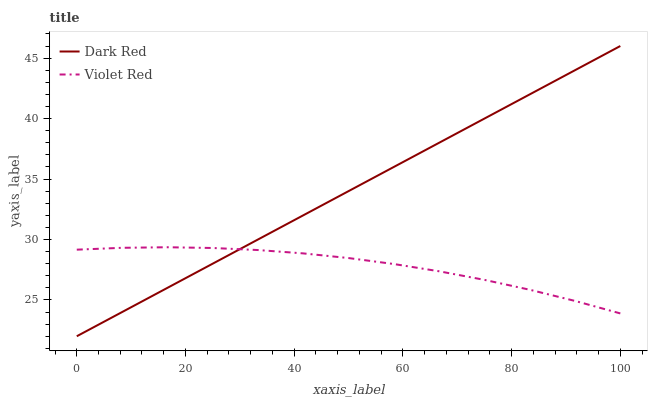Does Violet Red have the minimum area under the curve?
Answer yes or no. Yes. Does Dark Red have the maximum area under the curve?
Answer yes or no. Yes. Does Violet Red have the maximum area under the curve?
Answer yes or no. No. Is Dark Red the smoothest?
Answer yes or no. Yes. Is Violet Red the roughest?
Answer yes or no. Yes. Is Violet Red the smoothest?
Answer yes or no. No. Does Dark Red have the lowest value?
Answer yes or no. Yes. Does Violet Red have the lowest value?
Answer yes or no. No. Does Dark Red have the highest value?
Answer yes or no. Yes. Does Violet Red have the highest value?
Answer yes or no. No. Does Dark Red intersect Violet Red?
Answer yes or no. Yes. Is Dark Red less than Violet Red?
Answer yes or no. No. Is Dark Red greater than Violet Red?
Answer yes or no. No. 